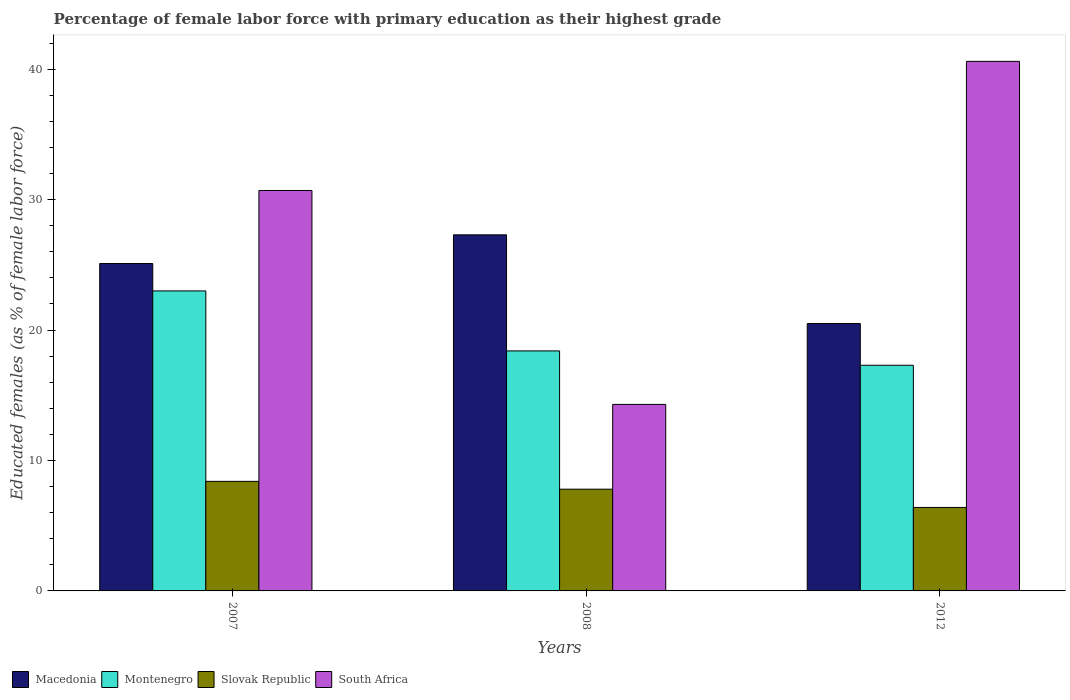How many different coloured bars are there?
Offer a terse response. 4. How many groups of bars are there?
Ensure brevity in your answer.  3. Are the number of bars per tick equal to the number of legend labels?
Provide a short and direct response. Yes. Are the number of bars on each tick of the X-axis equal?
Your answer should be compact. Yes. How many bars are there on the 2nd tick from the left?
Keep it short and to the point. 4. Across all years, what is the maximum percentage of female labor force with primary education in South Africa?
Your response must be concise. 40.6. Across all years, what is the minimum percentage of female labor force with primary education in Slovak Republic?
Ensure brevity in your answer.  6.4. In which year was the percentage of female labor force with primary education in South Africa minimum?
Offer a terse response. 2008. What is the total percentage of female labor force with primary education in Macedonia in the graph?
Make the answer very short. 72.9. What is the difference between the percentage of female labor force with primary education in Macedonia in 2007 and that in 2008?
Provide a short and direct response. -2.2. What is the difference between the percentage of female labor force with primary education in Macedonia in 2008 and the percentage of female labor force with primary education in Montenegro in 2012?
Ensure brevity in your answer.  10. What is the average percentage of female labor force with primary education in Slovak Republic per year?
Ensure brevity in your answer.  7.53. In the year 2012, what is the difference between the percentage of female labor force with primary education in South Africa and percentage of female labor force with primary education in Slovak Republic?
Offer a very short reply. 34.2. In how many years, is the percentage of female labor force with primary education in Slovak Republic greater than 32 %?
Provide a succinct answer. 0. What is the ratio of the percentage of female labor force with primary education in Montenegro in 2007 to that in 2012?
Ensure brevity in your answer.  1.33. Is the difference between the percentage of female labor force with primary education in South Africa in 2007 and 2012 greater than the difference between the percentage of female labor force with primary education in Slovak Republic in 2007 and 2012?
Give a very brief answer. No. What is the difference between the highest and the second highest percentage of female labor force with primary education in Slovak Republic?
Offer a terse response. 0.6. What is the difference between the highest and the lowest percentage of female labor force with primary education in Macedonia?
Your answer should be very brief. 6.8. In how many years, is the percentage of female labor force with primary education in Montenegro greater than the average percentage of female labor force with primary education in Montenegro taken over all years?
Provide a short and direct response. 1. What does the 2nd bar from the left in 2012 represents?
Give a very brief answer. Montenegro. What does the 4th bar from the right in 2012 represents?
Make the answer very short. Macedonia. How many bars are there?
Provide a short and direct response. 12. How many years are there in the graph?
Your answer should be very brief. 3. What is the difference between two consecutive major ticks on the Y-axis?
Provide a short and direct response. 10. Are the values on the major ticks of Y-axis written in scientific E-notation?
Offer a very short reply. No. Does the graph contain grids?
Your answer should be very brief. No. What is the title of the graph?
Your response must be concise. Percentage of female labor force with primary education as their highest grade. Does "OECD members" appear as one of the legend labels in the graph?
Provide a short and direct response. No. What is the label or title of the Y-axis?
Your answer should be compact. Educated females (as % of female labor force). What is the Educated females (as % of female labor force) in Macedonia in 2007?
Ensure brevity in your answer.  25.1. What is the Educated females (as % of female labor force) in Montenegro in 2007?
Your answer should be compact. 23. What is the Educated females (as % of female labor force) in Slovak Republic in 2007?
Keep it short and to the point. 8.4. What is the Educated females (as % of female labor force) in South Africa in 2007?
Your answer should be very brief. 30.7. What is the Educated females (as % of female labor force) in Macedonia in 2008?
Your answer should be compact. 27.3. What is the Educated females (as % of female labor force) in Montenegro in 2008?
Your answer should be compact. 18.4. What is the Educated females (as % of female labor force) in Slovak Republic in 2008?
Keep it short and to the point. 7.8. What is the Educated females (as % of female labor force) in South Africa in 2008?
Give a very brief answer. 14.3. What is the Educated females (as % of female labor force) in Montenegro in 2012?
Your response must be concise. 17.3. What is the Educated females (as % of female labor force) of Slovak Republic in 2012?
Offer a terse response. 6.4. What is the Educated females (as % of female labor force) in South Africa in 2012?
Your answer should be very brief. 40.6. Across all years, what is the maximum Educated females (as % of female labor force) in Macedonia?
Offer a very short reply. 27.3. Across all years, what is the maximum Educated females (as % of female labor force) of Slovak Republic?
Provide a succinct answer. 8.4. Across all years, what is the maximum Educated females (as % of female labor force) of South Africa?
Keep it short and to the point. 40.6. Across all years, what is the minimum Educated females (as % of female labor force) in Montenegro?
Provide a short and direct response. 17.3. Across all years, what is the minimum Educated females (as % of female labor force) of Slovak Republic?
Your response must be concise. 6.4. Across all years, what is the minimum Educated females (as % of female labor force) of South Africa?
Your answer should be compact. 14.3. What is the total Educated females (as % of female labor force) of Macedonia in the graph?
Give a very brief answer. 72.9. What is the total Educated females (as % of female labor force) in Montenegro in the graph?
Make the answer very short. 58.7. What is the total Educated females (as % of female labor force) in Slovak Republic in the graph?
Make the answer very short. 22.6. What is the total Educated females (as % of female labor force) of South Africa in the graph?
Provide a short and direct response. 85.6. What is the difference between the Educated females (as % of female labor force) of South Africa in 2007 and that in 2008?
Offer a terse response. 16.4. What is the difference between the Educated females (as % of female labor force) of Macedonia in 2007 and that in 2012?
Provide a succinct answer. 4.6. What is the difference between the Educated females (as % of female labor force) in Macedonia in 2008 and that in 2012?
Your answer should be very brief. 6.8. What is the difference between the Educated females (as % of female labor force) of Montenegro in 2008 and that in 2012?
Provide a short and direct response. 1.1. What is the difference between the Educated females (as % of female labor force) of Slovak Republic in 2008 and that in 2012?
Your response must be concise. 1.4. What is the difference between the Educated females (as % of female labor force) of South Africa in 2008 and that in 2012?
Your response must be concise. -26.3. What is the difference between the Educated females (as % of female labor force) of Macedonia in 2007 and the Educated females (as % of female labor force) of South Africa in 2008?
Make the answer very short. 10.8. What is the difference between the Educated females (as % of female labor force) of Montenegro in 2007 and the Educated females (as % of female labor force) of Slovak Republic in 2008?
Provide a short and direct response. 15.2. What is the difference between the Educated females (as % of female labor force) of Macedonia in 2007 and the Educated females (as % of female labor force) of Slovak Republic in 2012?
Your answer should be very brief. 18.7. What is the difference between the Educated females (as % of female labor force) of Macedonia in 2007 and the Educated females (as % of female labor force) of South Africa in 2012?
Your answer should be compact. -15.5. What is the difference between the Educated females (as % of female labor force) of Montenegro in 2007 and the Educated females (as % of female labor force) of Slovak Republic in 2012?
Your response must be concise. 16.6. What is the difference between the Educated females (as % of female labor force) in Montenegro in 2007 and the Educated females (as % of female labor force) in South Africa in 2012?
Provide a short and direct response. -17.6. What is the difference between the Educated females (as % of female labor force) of Slovak Republic in 2007 and the Educated females (as % of female labor force) of South Africa in 2012?
Ensure brevity in your answer.  -32.2. What is the difference between the Educated females (as % of female labor force) in Macedonia in 2008 and the Educated females (as % of female labor force) in Montenegro in 2012?
Your answer should be compact. 10. What is the difference between the Educated females (as % of female labor force) in Macedonia in 2008 and the Educated females (as % of female labor force) in Slovak Republic in 2012?
Provide a short and direct response. 20.9. What is the difference between the Educated females (as % of female labor force) in Macedonia in 2008 and the Educated females (as % of female labor force) in South Africa in 2012?
Give a very brief answer. -13.3. What is the difference between the Educated females (as % of female labor force) in Montenegro in 2008 and the Educated females (as % of female labor force) in Slovak Republic in 2012?
Your answer should be compact. 12. What is the difference between the Educated females (as % of female labor force) of Montenegro in 2008 and the Educated females (as % of female labor force) of South Africa in 2012?
Offer a very short reply. -22.2. What is the difference between the Educated females (as % of female labor force) of Slovak Republic in 2008 and the Educated females (as % of female labor force) of South Africa in 2012?
Keep it short and to the point. -32.8. What is the average Educated females (as % of female labor force) of Macedonia per year?
Offer a terse response. 24.3. What is the average Educated females (as % of female labor force) in Montenegro per year?
Your answer should be very brief. 19.57. What is the average Educated females (as % of female labor force) of Slovak Republic per year?
Offer a very short reply. 7.53. What is the average Educated females (as % of female labor force) of South Africa per year?
Your response must be concise. 28.53. In the year 2007, what is the difference between the Educated females (as % of female labor force) of Macedonia and Educated females (as % of female labor force) of Montenegro?
Give a very brief answer. 2.1. In the year 2007, what is the difference between the Educated females (as % of female labor force) in Macedonia and Educated females (as % of female labor force) in South Africa?
Keep it short and to the point. -5.6. In the year 2007, what is the difference between the Educated females (as % of female labor force) of Montenegro and Educated females (as % of female labor force) of Slovak Republic?
Keep it short and to the point. 14.6. In the year 2007, what is the difference between the Educated females (as % of female labor force) of Montenegro and Educated females (as % of female labor force) of South Africa?
Offer a terse response. -7.7. In the year 2007, what is the difference between the Educated females (as % of female labor force) of Slovak Republic and Educated females (as % of female labor force) of South Africa?
Your response must be concise. -22.3. In the year 2008, what is the difference between the Educated females (as % of female labor force) of Macedonia and Educated females (as % of female labor force) of Montenegro?
Offer a terse response. 8.9. In the year 2008, what is the difference between the Educated females (as % of female labor force) in Montenegro and Educated females (as % of female labor force) in Slovak Republic?
Your answer should be compact. 10.6. In the year 2008, what is the difference between the Educated females (as % of female labor force) of Montenegro and Educated females (as % of female labor force) of South Africa?
Your answer should be compact. 4.1. In the year 2012, what is the difference between the Educated females (as % of female labor force) in Macedonia and Educated females (as % of female labor force) in South Africa?
Your answer should be very brief. -20.1. In the year 2012, what is the difference between the Educated females (as % of female labor force) of Montenegro and Educated females (as % of female labor force) of South Africa?
Your answer should be very brief. -23.3. In the year 2012, what is the difference between the Educated females (as % of female labor force) of Slovak Republic and Educated females (as % of female labor force) of South Africa?
Ensure brevity in your answer.  -34.2. What is the ratio of the Educated females (as % of female labor force) of Macedonia in 2007 to that in 2008?
Your answer should be compact. 0.92. What is the ratio of the Educated females (as % of female labor force) of South Africa in 2007 to that in 2008?
Keep it short and to the point. 2.15. What is the ratio of the Educated females (as % of female labor force) of Macedonia in 2007 to that in 2012?
Provide a short and direct response. 1.22. What is the ratio of the Educated females (as % of female labor force) of Montenegro in 2007 to that in 2012?
Give a very brief answer. 1.33. What is the ratio of the Educated females (as % of female labor force) in Slovak Republic in 2007 to that in 2012?
Provide a short and direct response. 1.31. What is the ratio of the Educated females (as % of female labor force) in South Africa in 2007 to that in 2012?
Give a very brief answer. 0.76. What is the ratio of the Educated females (as % of female labor force) in Macedonia in 2008 to that in 2012?
Provide a short and direct response. 1.33. What is the ratio of the Educated females (as % of female labor force) of Montenegro in 2008 to that in 2012?
Your answer should be compact. 1.06. What is the ratio of the Educated females (as % of female labor force) of Slovak Republic in 2008 to that in 2012?
Your answer should be compact. 1.22. What is the ratio of the Educated females (as % of female labor force) in South Africa in 2008 to that in 2012?
Keep it short and to the point. 0.35. What is the difference between the highest and the second highest Educated females (as % of female labor force) of Macedonia?
Give a very brief answer. 2.2. What is the difference between the highest and the lowest Educated females (as % of female labor force) in Montenegro?
Give a very brief answer. 5.7. What is the difference between the highest and the lowest Educated females (as % of female labor force) in South Africa?
Your answer should be compact. 26.3. 